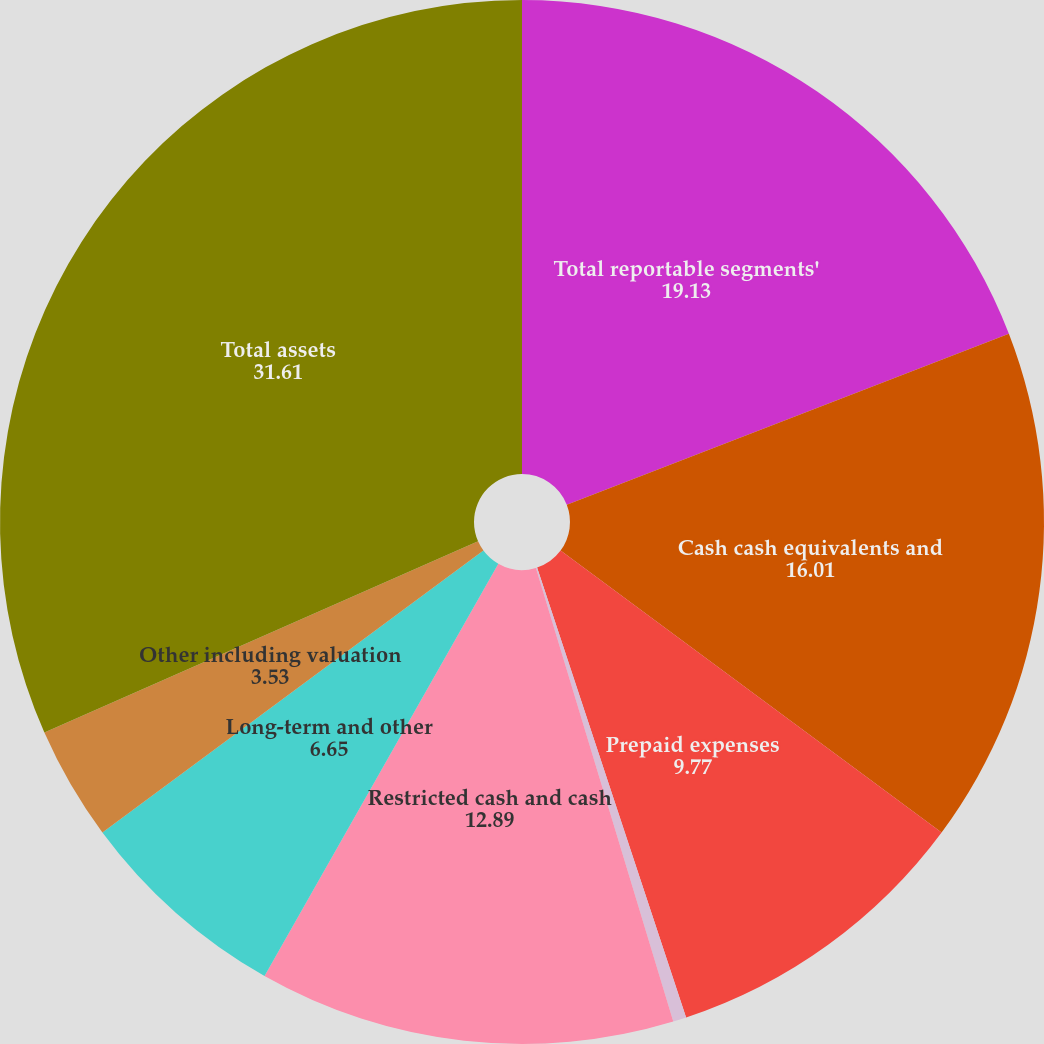<chart> <loc_0><loc_0><loc_500><loc_500><pie_chart><fcel>Total reportable segments'<fcel>Cash cash equivalents and<fcel>Prepaid expenses<fcel>Cost method investments<fcel>Restricted cash and cash<fcel>Long-term and other<fcel>Other including valuation<fcel>Total assets<nl><fcel>19.13%<fcel>16.01%<fcel>9.77%<fcel>0.41%<fcel>12.89%<fcel>6.65%<fcel>3.53%<fcel>31.61%<nl></chart> 